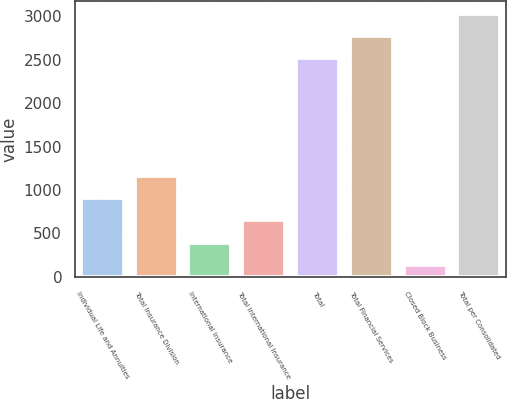Convert chart. <chart><loc_0><loc_0><loc_500><loc_500><bar_chart><fcel>Individual Life and Annuities<fcel>Total Insurance Division<fcel>International Insurance<fcel>Total International Insurance<fcel>Total<fcel>Total Financial Services<fcel>Closed Block Business<fcel>Total per Consolidated<nl><fcel>905.6<fcel>1161.8<fcel>393.2<fcel>649.4<fcel>2516<fcel>2772.2<fcel>137<fcel>3028.4<nl></chart> 